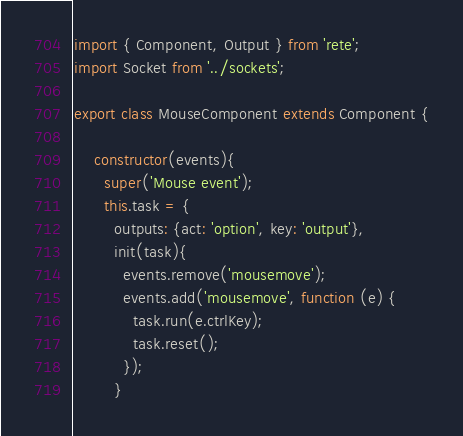<code> <loc_0><loc_0><loc_500><loc_500><_JavaScript_>import { Component, Output } from 'rete';
import Socket from '../sockets';

export class MouseComponent extends Component {
  
    constructor(events){
      super('Mouse event');
      this.task = {
        outputs: {act: 'option', key: 'output'},
        init(task){
          events.remove('mousemove');
          events.add('mousemove', function (e) {
            task.run(e.ctrlKey);
            task.reset();
          });
        }</code> 